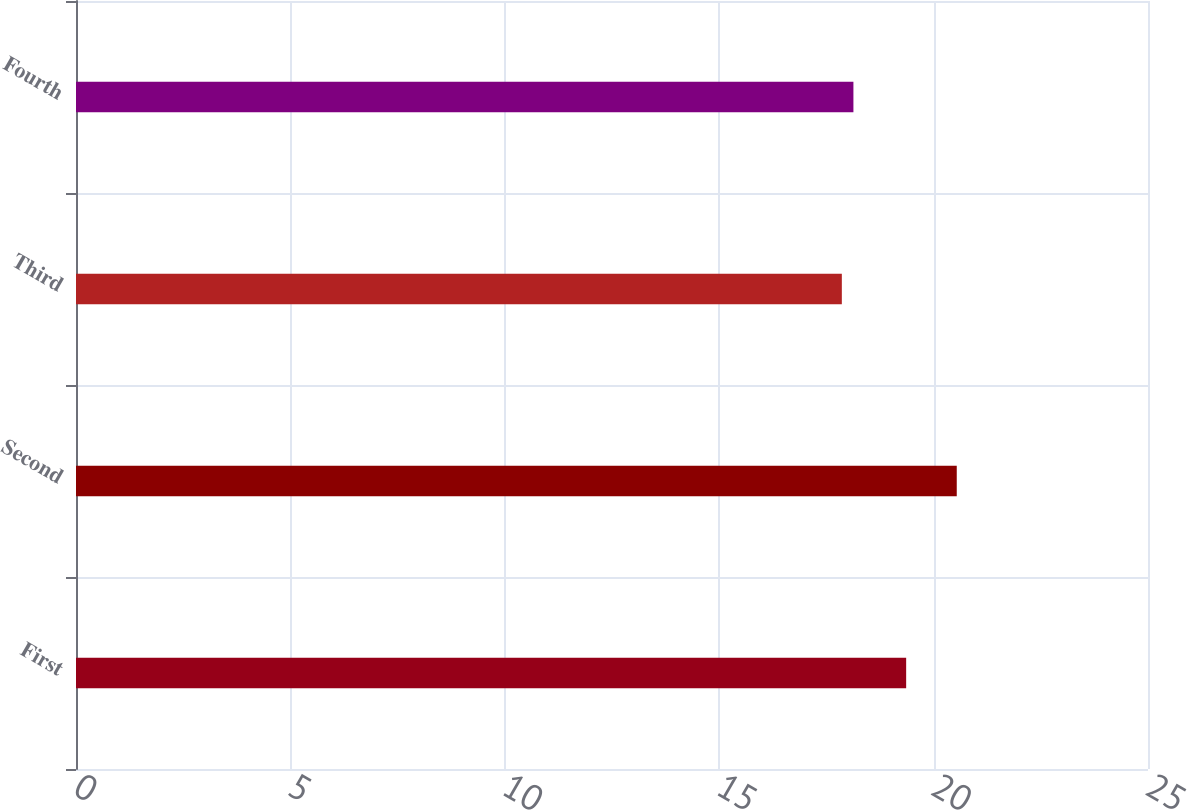<chart> <loc_0><loc_0><loc_500><loc_500><bar_chart><fcel>First<fcel>Second<fcel>Third<fcel>Fourth<nl><fcel>19.36<fcel>20.54<fcel>17.86<fcel>18.13<nl></chart> 